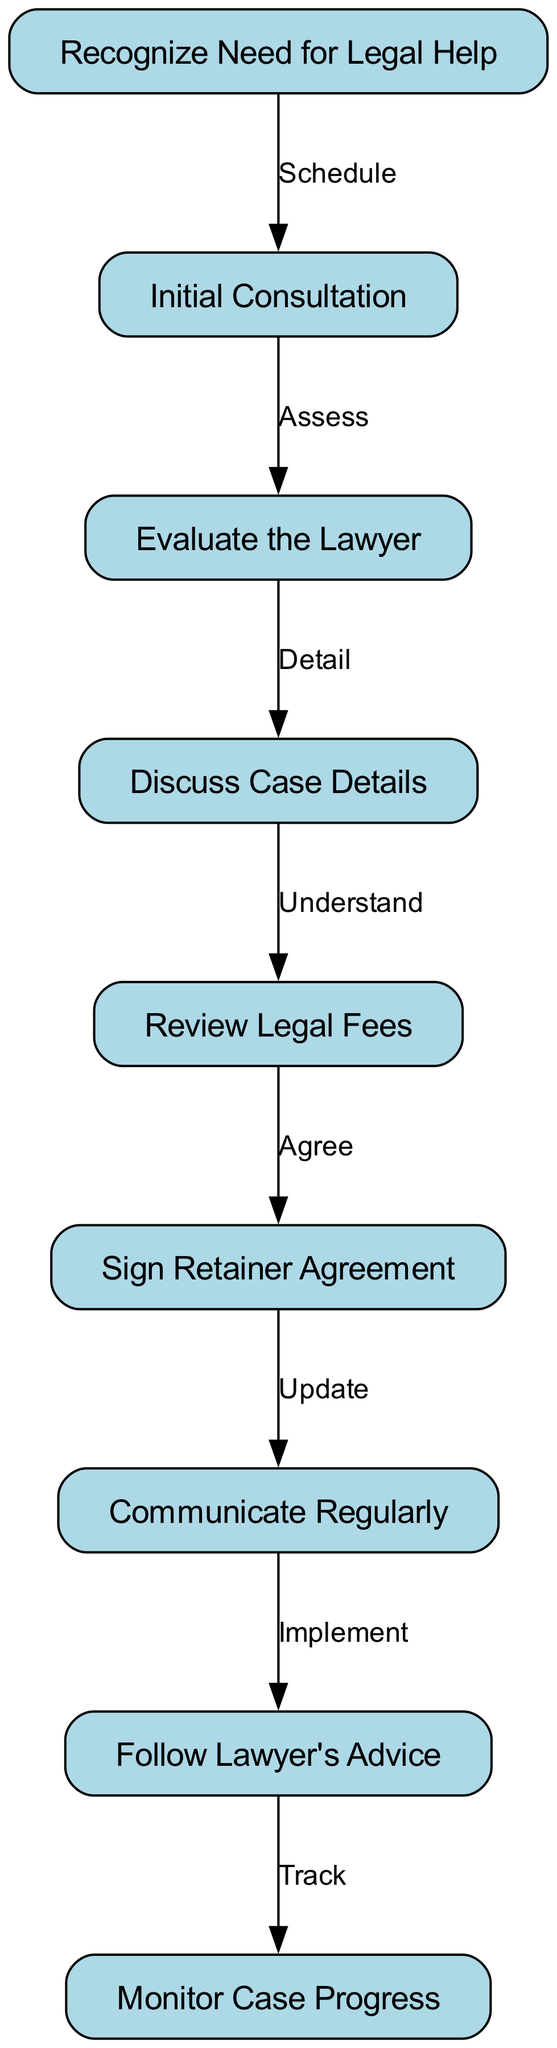What is the first step in hiring a personal injury lawyer? The first step is to recognize the need for legal help, as indicated by the first node in the diagram. It is the starting point for the entire process.
Answer: Recognize Need for Legal Help How many nodes are there in the diagram? By counting all the individual elements in the nodes list, we find there are a total of nine distinct steps represented in the process.
Answer: 9 What is the relationship between the "Initial Consultation" and "Evaluate the Lawyer"? The relationship is indicated by the directed edge that connects the second node ("Initial Consultation") to the third node ("Evaluate the Lawyer"), labeled as "Assess". This shows the flow from one action to the next.
Answer: Assess Which step follows "Sign Retainer Agreement"? The next step after "Sign Retainer Agreement" is "Communicate Regularly" as shown by the directed edge that connects node six to node seven.
Answer: Communicate Regularly What is the last action in the hiring process? The last action in the process is represented by the ninth node, which is "Monitor Case Progress" and is the concluding step after implementing the lawyer's advice.
Answer: Monitor Case Progress What steps are involved after discussing case details? After discussing case details, the following steps are to review legal fees, then sign the retainer agreement. This is inferred by following the edges from node four to nodes five and six consecutively.
Answer: Review Legal Fees, Sign Retainer Agreement How many edges are there in the diagram? The total number of edges can be determined by counting the directed connections between nodes, which amounts to eight in this case.
Answer: 8 